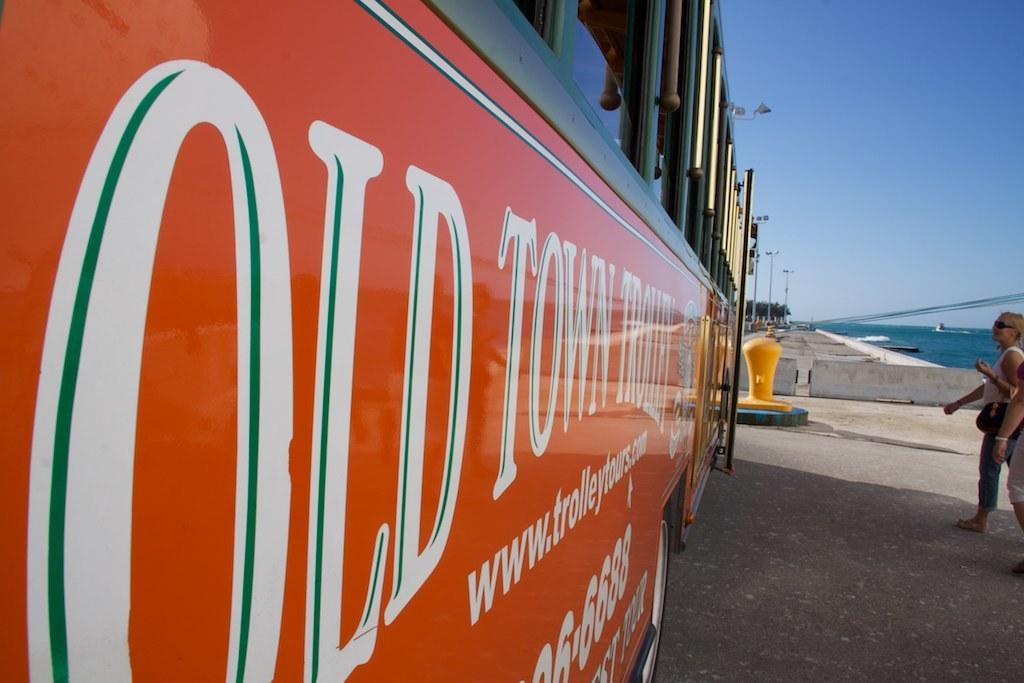<image>
Share a concise interpretation of the image provided. A red sign with white letters that reads OLD TOWN TROLLEY 